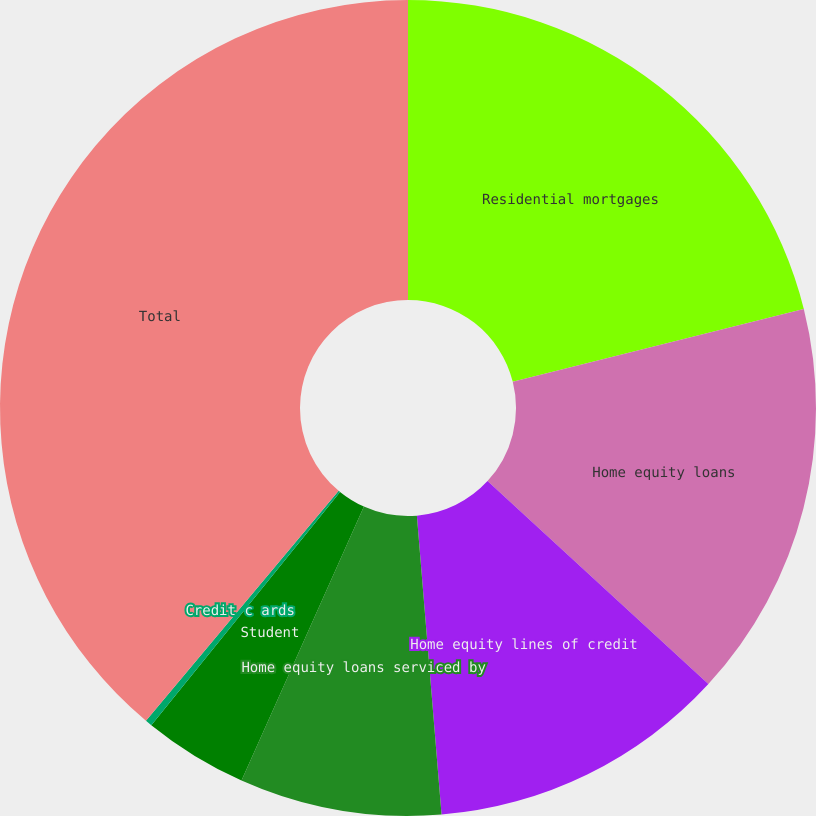Convert chart. <chart><loc_0><loc_0><loc_500><loc_500><pie_chart><fcel>Residential mortgages<fcel>Home equity loans<fcel>Home equity lines of credit<fcel>Home equity loans serviced by<fcel>Student<fcel>Credit c ards<fcel>Total<nl><fcel>21.1%<fcel>15.73%<fcel>11.86%<fcel>8.0%<fcel>4.14%<fcel>0.27%<fcel>38.9%<nl></chart> 